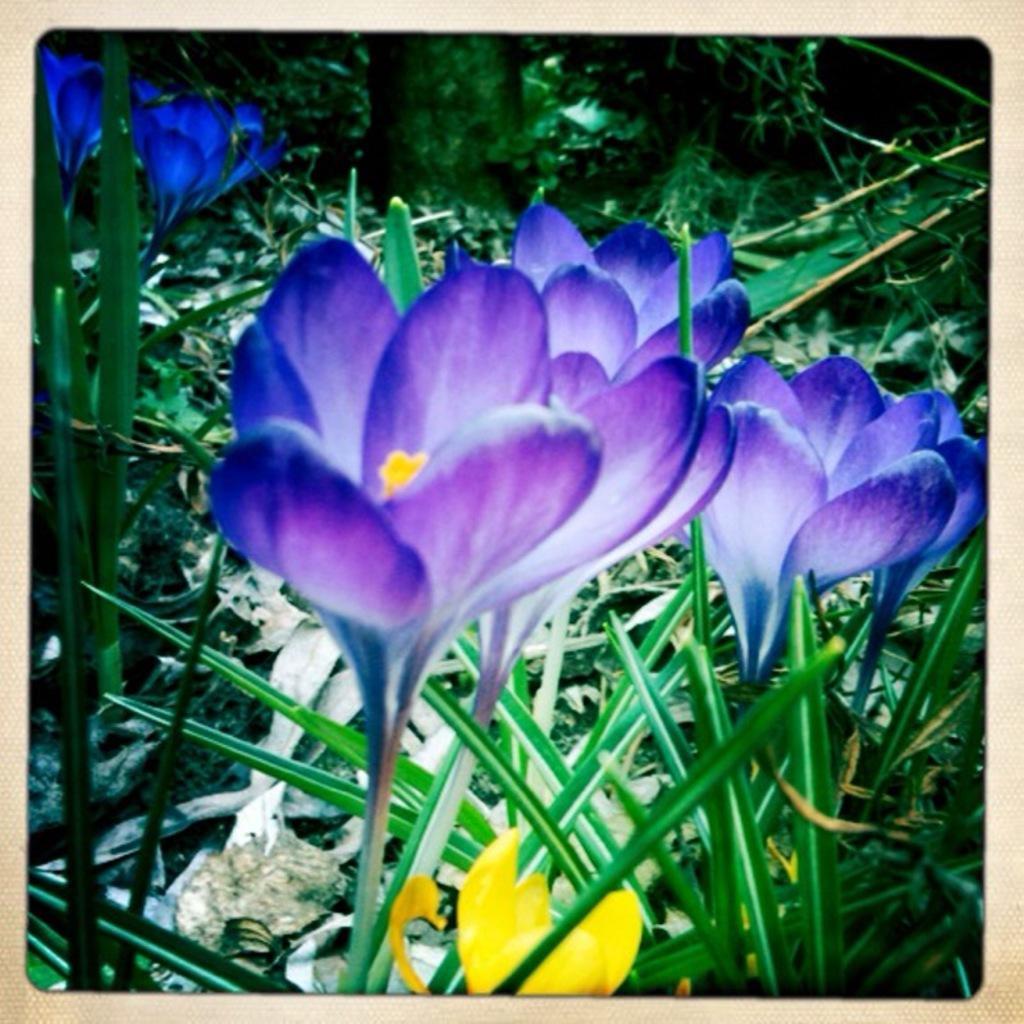Describe this image in one or two sentences. There are plants having violet color flowers and there are some plants having yellow color flowers. In the background, there are plants and trees. 